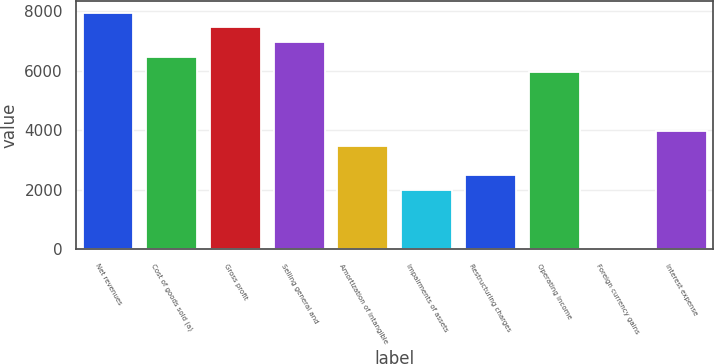Convert chart. <chart><loc_0><loc_0><loc_500><loc_500><bar_chart><fcel>Net revenues<fcel>Cost of goods sold (a)<fcel>Gross profit<fcel>Selling general and<fcel>Amortization of intangible<fcel>Impairments of assets<fcel>Restructuring charges<fcel>Operating income<fcel>Foreign currency gains<fcel>Interest expense<nl><fcel>7964.92<fcel>6471.91<fcel>7467.25<fcel>6969.58<fcel>3485.89<fcel>1992.88<fcel>2490.55<fcel>5974.24<fcel>2.2<fcel>3983.56<nl></chart> 